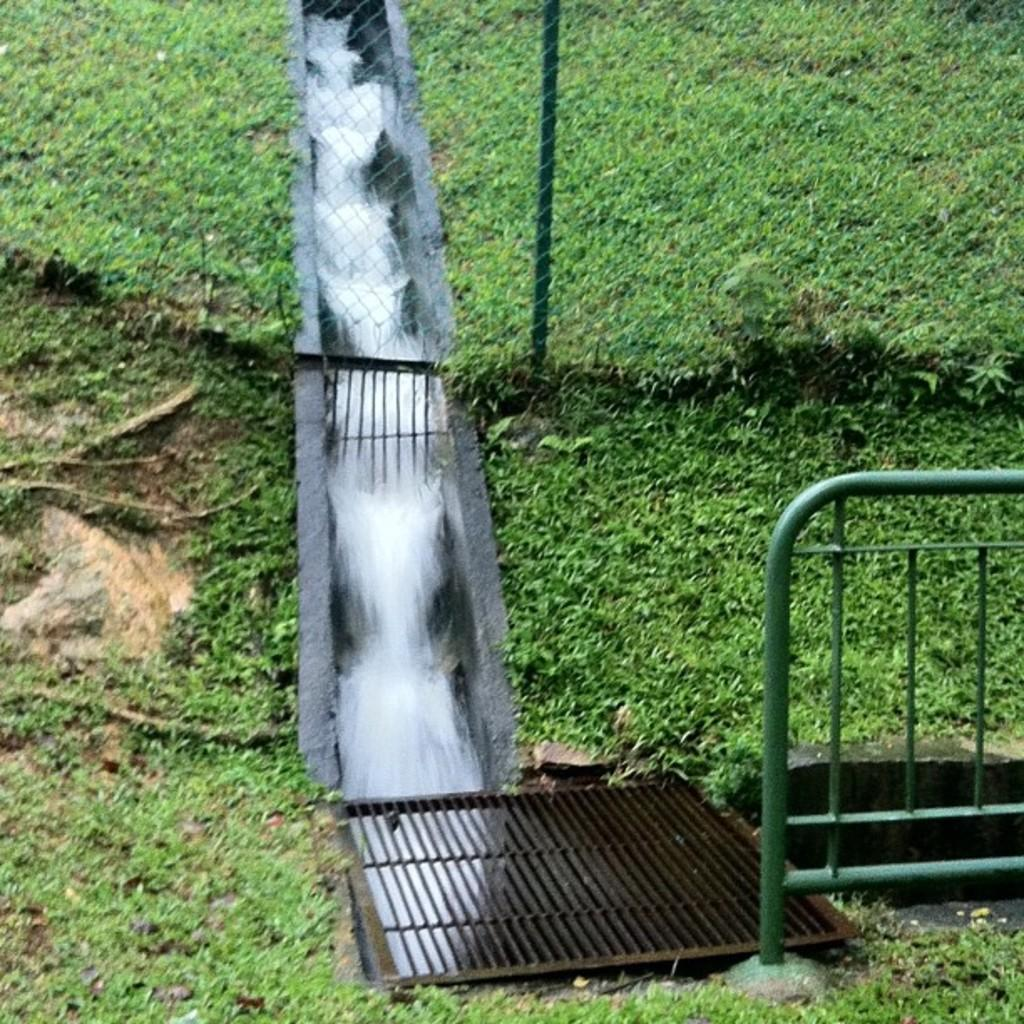What is happening in the image? There is water flowing in the image. What is the water flowing over? The water is flowing over a structure that resembles a dam. What can be seen near the water? There is a railing and a grille in the image. What type of vegetation is present in the image? Grass is present in the image. What type of machine can be seen coughing in the image? There is no machine or coughing sound present in the image. 